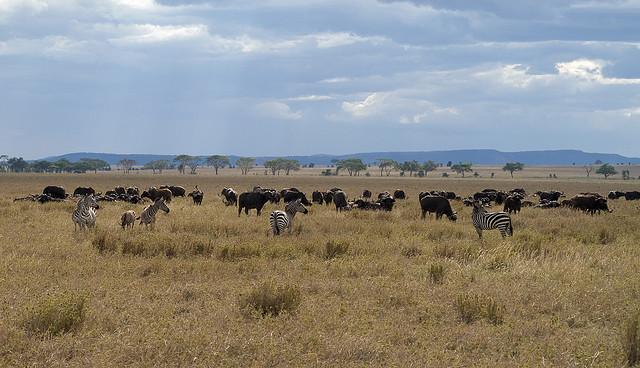What's in the distance beyond the animals?
Write a very short answer. Mountains. Are all the animals elephants?
Answer briefly. No. Are the animals in an enclosure?
Short answer required. No. What is in the field with the elephants?
Concise answer only. Zebras. How many zebras can be seen?
Be succinct. 4. How many animals are in the scene?
Be succinct. 50. Is there water in the photo?
Concise answer only. No. Are there zebras?
Concise answer only. Yes. 